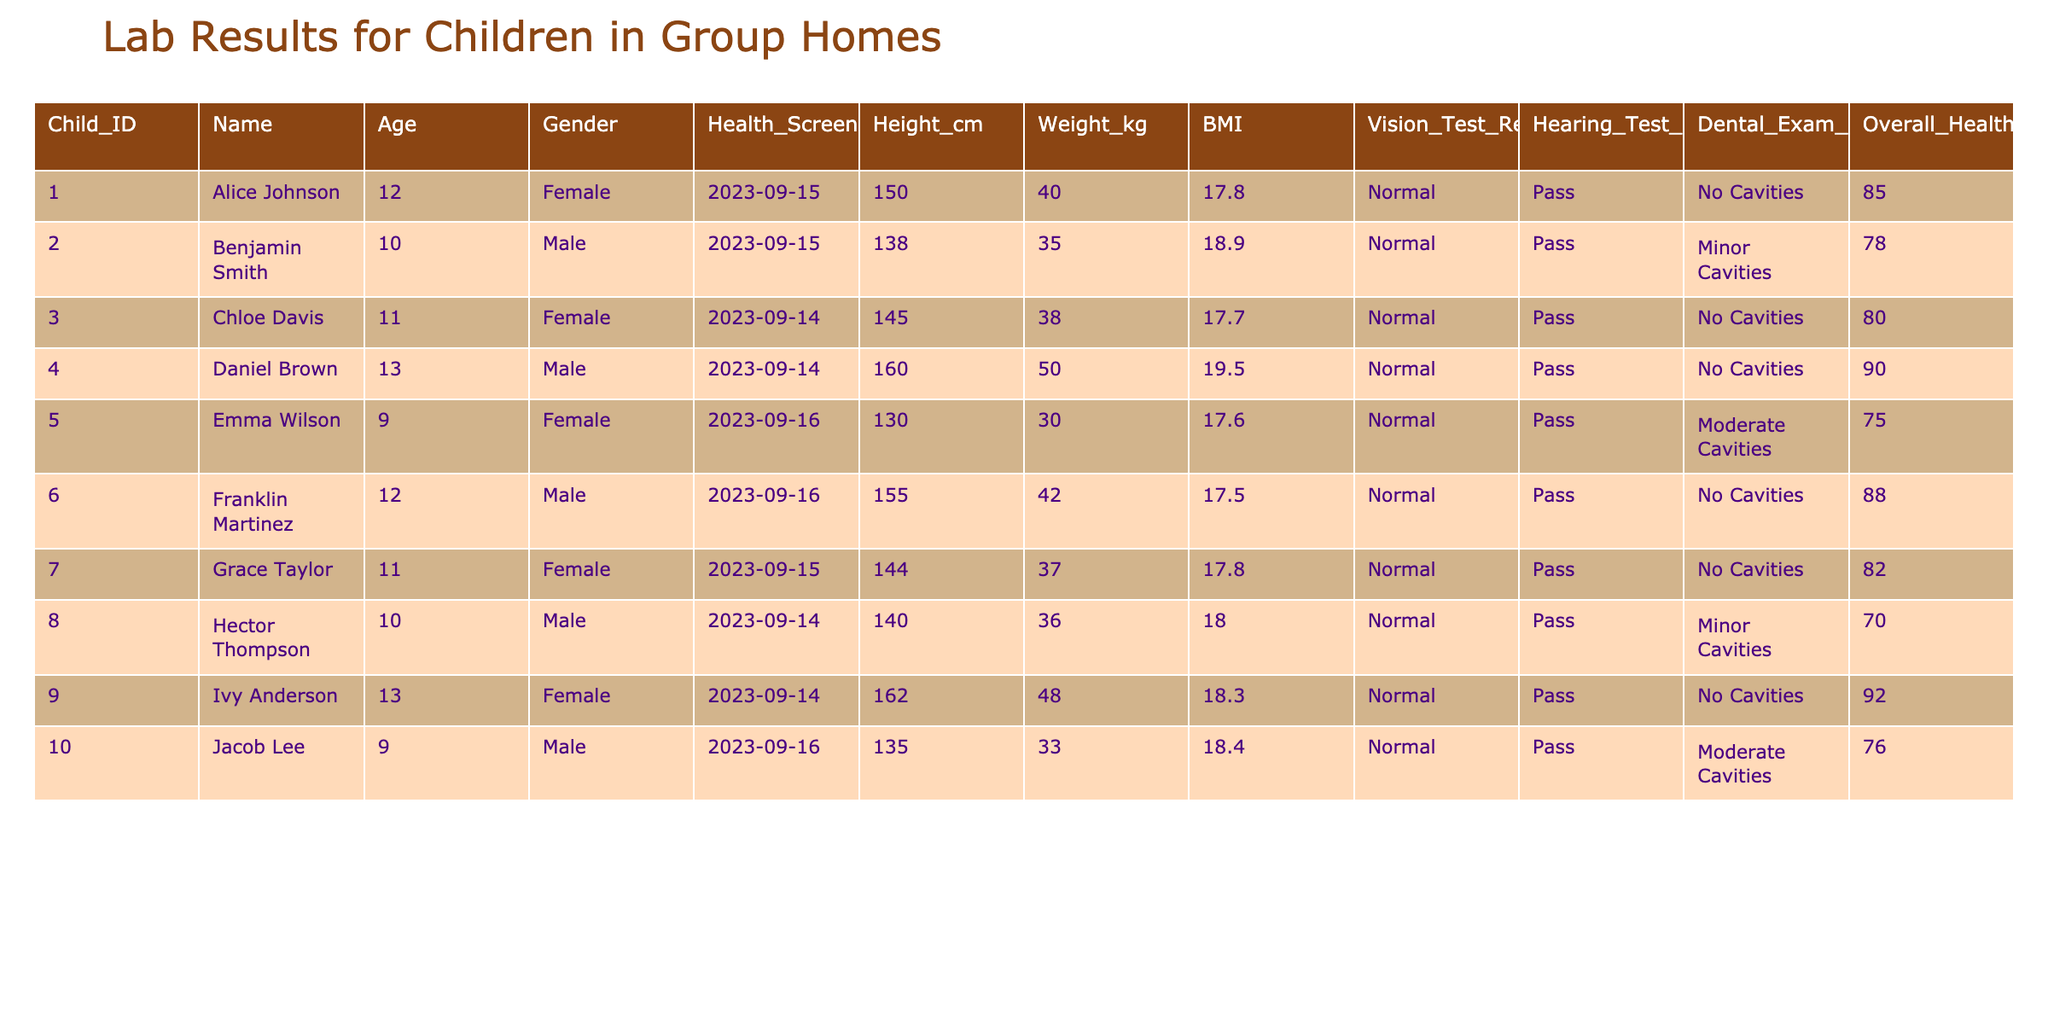What is the highest overall health score among the children? The health scores for the children are as follows: 85, 78, 80, 90, 75, 88, 82, 70, 92, and 76. The highest score in this list is 92, which belongs to Ivy Anderson.
Answer: 92 How many children passed the hearing test? All the children in the table have a "Pass" result for the hearing test. Since there are 10 children in total, the number who passed the test is 10.
Answer: 10 What is the average BMI of the children in the table? The BMI values are: 17.8, 18.9, 17.7, 19.5, 17.6, 17.5, 17.8, 18.0, 18.3, and 18.4. To find the average, we sum them up: (17.8 + 18.9 + 17.7 + 19.5 + 17.6 + 17.5 + 17.8 + 18.0 + 18.3 + 18.4) = 179.5. We then divide by the number of children: 179.5 / 10 = 17.95.
Answer: 17.95 Are there any children with no cavities? By inspecting the dental exam results, we see that Alice Johnson, Chloe Davis, Daniel Brown, Franklin Martinez, Grace Taylor, and Ivy Anderson have “No Cavities.” Therefore, there are 6 children with no cavities.
Answer: Yes What is the weight difference between the lightest and heaviest child? The weights from the table are: 40, 35, 38, 50, 30, 42, 37, 36, 48, and 33. The lightest child is Emma Wilson, weighing 30 kg, and the heaviest child is Daniel Brown, weighing 50 kg. The weight difference is calculated as 50 - 30 = 20 kg.
Answer: 20 kg Which gender has the highest average score in the overall health score? The overall health scores for girls (Alice Johnson, Chloe Davis, Emma Wilson, Grace Taylor, Ivy Anderson) are: 85, 80, 75, 82, 92. The average for girls is (85 + 80 + 75 + 82 + 92) / 5 = 82.8. The scores for boys (Benjamin Smith, Daniel Brown, Franklin Martinez, Hector Thompson, Jacob Lee) are: 78, 90, 88, 70, 76. The average for boys: (78 + 90 + 88 + 70 + 76) / 5 = 80.4. Since 82.8 (girls) is higher than 80.4 (boys), girls have the highest average score.
Answer: Girls Who has the lowest vision test result? All children have a "Normal" vision test result. Therefore, there is no child that has a result lower than "Normal."
Answer: No What percentage of children have minor or moderate cavities? The children with cavities are Benjamin Smith (Minor), Emma Wilson (Moderate), and Hector Thompson (Minor). That totals to 3 out of 10 children. To find the percentage: (3 / 10) * 100 = 30%.
Answer: 30% 